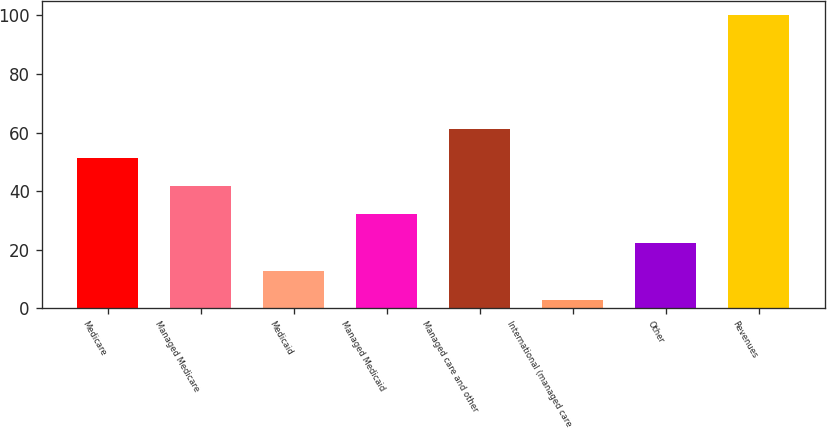Convert chart. <chart><loc_0><loc_0><loc_500><loc_500><bar_chart><fcel>Medicare<fcel>Managed Medicare<fcel>Medicaid<fcel>Managed Medicaid<fcel>Managed care and other<fcel>International (managed care<fcel>Other<fcel>Revenues<nl><fcel>51.45<fcel>41.74<fcel>12.61<fcel>32.03<fcel>61.16<fcel>2.9<fcel>22.32<fcel>100<nl></chart> 